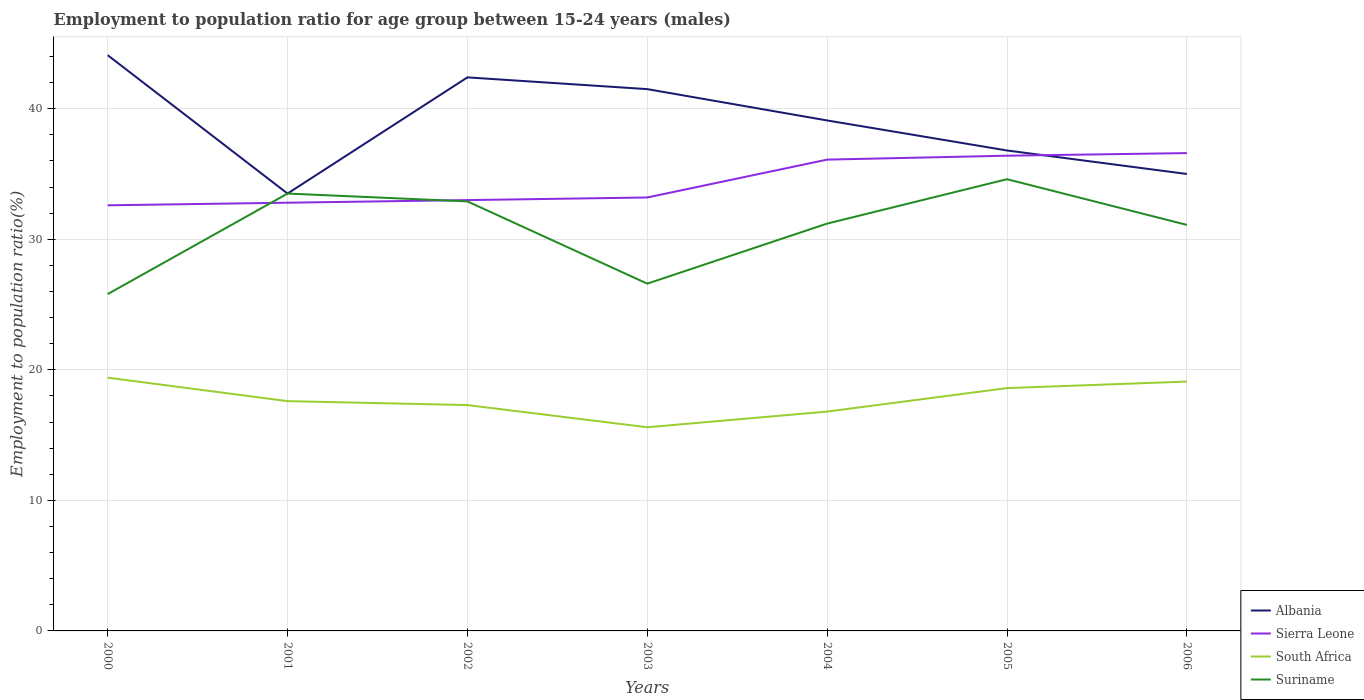How many different coloured lines are there?
Provide a short and direct response. 4. Does the line corresponding to Suriname intersect with the line corresponding to South Africa?
Provide a succinct answer. No. Is the number of lines equal to the number of legend labels?
Make the answer very short. Yes. Across all years, what is the maximum employment to population ratio in Albania?
Your answer should be very brief. 33.5. What is the total employment to population ratio in Suriname in the graph?
Offer a very short reply. -5.4. What is the difference between the highest and the second highest employment to population ratio in Sierra Leone?
Your response must be concise. 4. How many lines are there?
Provide a short and direct response. 4. What is the difference between two consecutive major ticks on the Y-axis?
Your response must be concise. 10. Does the graph contain any zero values?
Your answer should be very brief. No. What is the title of the graph?
Your answer should be very brief. Employment to population ratio for age group between 15-24 years (males). What is the Employment to population ratio(%) in Albania in 2000?
Your answer should be compact. 44.1. What is the Employment to population ratio(%) in Sierra Leone in 2000?
Provide a succinct answer. 32.6. What is the Employment to population ratio(%) in South Africa in 2000?
Your response must be concise. 19.4. What is the Employment to population ratio(%) of Suriname in 2000?
Your answer should be very brief. 25.8. What is the Employment to population ratio(%) in Albania in 2001?
Your answer should be very brief. 33.5. What is the Employment to population ratio(%) in Sierra Leone in 2001?
Give a very brief answer. 32.8. What is the Employment to population ratio(%) of South Africa in 2001?
Make the answer very short. 17.6. What is the Employment to population ratio(%) in Suriname in 2001?
Offer a terse response. 33.5. What is the Employment to population ratio(%) in Albania in 2002?
Ensure brevity in your answer.  42.4. What is the Employment to population ratio(%) of Sierra Leone in 2002?
Give a very brief answer. 33. What is the Employment to population ratio(%) of South Africa in 2002?
Provide a short and direct response. 17.3. What is the Employment to population ratio(%) in Suriname in 2002?
Offer a very short reply. 32.9. What is the Employment to population ratio(%) of Albania in 2003?
Your answer should be compact. 41.5. What is the Employment to population ratio(%) of Sierra Leone in 2003?
Provide a short and direct response. 33.2. What is the Employment to population ratio(%) of South Africa in 2003?
Your answer should be compact. 15.6. What is the Employment to population ratio(%) in Suriname in 2003?
Make the answer very short. 26.6. What is the Employment to population ratio(%) of Albania in 2004?
Give a very brief answer. 39.1. What is the Employment to population ratio(%) of Sierra Leone in 2004?
Offer a very short reply. 36.1. What is the Employment to population ratio(%) in South Africa in 2004?
Keep it short and to the point. 16.8. What is the Employment to population ratio(%) of Suriname in 2004?
Keep it short and to the point. 31.2. What is the Employment to population ratio(%) in Albania in 2005?
Offer a very short reply. 36.8. What is the Employment to population ratio(%) in Sierra Leone in 2005?
Ensure brevity in your answer.  36.4. What is the Employment to population ratio(%) in South Africa in 2005?
Provide a succinct answer. 18.6. What is the Employment to population ratio(%) in Suriname in 2005?
Ensure brevity in your answer.  34.6. What is the Employment to population ratio(%) in Sierra Leone in 2006?
Your answer should be very brief. 36.6. What is the Employment to population ratio(%) of South Africa in 2006?
Offer a very short reply. 19.1. What is the Employment to population ratio(%) in Suriname in 2006?
Ensure brevity in your answer.  31.1. Across all years, what is the maximum Employment to population ratio(%) of Albania?
Your answer should be very brief. 44.1. Across all years, what is the maximum Employment to population ratio(%) of Sierra Leone?
Your answer should be compact. 36.6. Across all years, what is the maximum Employment to population ratio(%) of South Africa?
Your response must be concise. 19.4. Across all years, what is the maximum Employment to population ratio(%) in Suriname?
Make the answer very short. 34.6. Across all years, what is the minimum Employment to population ratio(%) in Albania?
Offer a very short reply. 33.5. Across all years, what is the minimum Employment to population ratio(%) of Sierra Leone?
Provide a short and direct response. 32.6. Across all years, what is the minimum Employment to population ratio(%) in South Africa?
Your answer should be compact. 15.6. Across all years, what is the minimum Employment to population ratio(%) of Suriname?
Your answer should be compact. 25.8. What is the total Employment to population ratio(%) of Albania in the graph?
Provide a short and direct response. 272.4. What is the total Employment to population ratio(%) of Sierra Leone in the graph?
Your answer should be very brief. 240.7. What is the total Employment to population ratio(%) of South Africa in the graph?
Your response must be concise. 124.4. What is the total Employment to population ratio(%) of Suriname in the graph?
Your answer should be compact. 215.7. What is the difference between the Employment to population ratio(%) in Sierra Leone in 2000 and that in 2001?
Offer a very short reply. -0.2. What is the difference between the Employment to population ratio(%) of Sierra Leone in 2000 and that in 2002?
Offer a terse response. -0.4. What is the difference between the Employment to population ratio(%) of Albania in 2000 and that in 2003?
Keep it short and to the point. 2.6. What is the difference between the Employment to population ratio(%) of Sierra Leone in 2000 and that in 2003?
Make the answer very short. -0.6. What is the difference between the Employment to population ratio(%) in South Africa in 2000 and that in 2003?
Provide a succinct answer. 3.8. What is the difference between the Employment to population ratio(%) in Suriname in 2000 and that in 2003?
Provide a short and direct response. -0.8. What is the difference between the Employment to population ratio(%) of Albania in 2000 and that in 2004?
Give a very brief answer. 5. What is the difference between the Employment to population ratio(%) in South Africa in 2000 and that in 2004?
Keep it short and to the point. 2.6. What is the difference between the Employment to population ratio(%) in Suriname in 2000 and that in 2004?
Make the answer very short. -5.4. What is the difference between the Employment to population ratio(%) of Sierra Leone in 2000 and that in 2005?
Provide a short and direct response. -3.8. What is the difference between the Employment to population ratio(%) in Sierra Leone in 2000 and that in 2006?
Provide a succinct answer. -4. What is the difference between the Employment to population ratio(%) of South Africa in 2000 and that in 2006?
Provide a succinct answer. 0.3. What is the difference between the Employment to population ratio(%) of Suriname in 2001 and that in 2002?
Offer a terse response. 0.6. What is the difference between the Employment to population ratio(%) in South Africa in 2001 and that in 2003?
Keep it short and to the point. 2. What is the difference between the Employment to population ratio(%) of Suriname in 2001 and that in 2003?
Your response must be concise. 6.9. What is the difference between the Employment to population ratio(%) of Albania in 2001 and that in 2004?
Provide a short and direct response. -5.6. What is the difference between the Employment to population ratio(%) of Sierra Leone in 2001 and that in 2005?
Provide a succinct answer. -3.6. What is the difference between the Employment to population ratio(%) of Suriname in 2001 and that in 2005?
Your answer should be very brief. -1.1. What is the difference between the Employment to population ratio(%) of Sierra Leone in 2001 and that in 2006?
Keep it short and to the point. -3.8. What is the difference between the Employment to population ratio(%) in Suriname in 2001 and that in 2006?
Offer a very short reply. 2.4. What is the difference between the Employment to population ratio(%) of Albania in 2002 and that in 2003?
Give a very brief answer. 0.9. What is the difference between the Employment to population ratio(%) in Sierra Leone in 2002 and that in 2003?
Provide a succinct answer. -0.2. What is the difference between the Employment to population ratio(%) of South Africa in 2002 and that in 2003?
Give a very brief answer. 1.7. What is the difference between the Employment to population ratio(%) of Sierra Leone in 2002 and that in 2004?
Keep it short and to the point. -3.1. What is the difference between the Employment to population ratio(%) in South Africa in 2002 and that in 2004?
Provide a succinct answer. 0.5. What is the difference between the Employment to population ratio(%) of Albania in 2002 and that in 2005?
Keep it short and to the point. 5.6. What is the difference between the Employment to population ratio(%) in South Africa in 2002 and that in 2005?
Your answer should be very brief. -1.3. What is the difference between the Employment to population ratio(%) of Sierra Leone in 2002 and that in 2006?
Provide a short and direct response. -3.6. What is the difference between the Employment to population ratio(%) in South Africa in 2003 and that in 2004?
Provide a short and direct response. -1.2. What is the difference between the Employment to population ratio(%) in Sierra Leone in 2003 and that in 2005?
Provide a short and direct response. -3.2. What is the difference between the Employment to population ratio(%) in South Africa in 2003 and that in 2005?
Offer a very short reply. -3. What is the difference between the Employment to population ratio(%) of Sierra Leone in 2003 and that in 2006?
Make the answer very short. -3.4. What is the difference between the Employment to population ratio(%) of South Africa in 2003 and that in 2006?
Provide a succinct answer. -3.5. What is the difference between the Employment to population ratio(%) of South Africa in 2004 and that in 2005?
Your answer should be compact. -1.8. What is the difference between the Employment to population ratio(%) in Albania in 2004 and that in 2006?
Make the answer very short. 4.1. What is the difference between the Employment to population ratio(%) in Sierra Leone in 2004 and that in 2006?
Your answer should be compact. -0.5. What is the difference between the Employment to population ratio(%) of Suriname in 2004 and that in 2006?
Make the answer very short. 0.1. What is the difference between the Employment to population ratio(%) of Albania in 2005 and that in 2006?
Your response must be concise. 1.8. What is the difference between the Employment to population ratio(%) in Sierra Leone in 2005 and that in 2006?
Your answer should be very brief. -0.2. What is the difference between the Employment to population ratio(%) of Suriname in 2005 and that in 2006?
Your answer should be compact. 3.5. What is the difference between the Employment to population ratio(%) in Sierra Leone in 2000 and the Employment to population ratio(%) in South Africa in 2001?
Your answer should be very brief. 15. What is the difference between the Employment to population ratio(%) of Sierra Leone in 2000 and the Employment to population ratio(%) of Suriname in 2001?
Keep it short and to the point. -0.9. What is the difference between the Employment to population ratio(%) of South Africa in 2000 and the Employment to population ratio(%) of Suriname in 2001?
Your answer should be very brief. -14.1. What is the difference between the Employment to population ratio(%) of Albania in 2000 and the Employment to population ratio(%) of Sierra Leone in 2002?
Ensure brevity in your answer.  11.1. What is the difference between the Employment to population ratio(%) of Albania in 2000 and the Employment to population ratio(%) of South Africa in 2002?
Ensure brevity in your answer.  26.8. What is the difference between the Employment to population ratio(%) in Sierra Leone in 2000 and the Employment to population ratio(%) in South Africa in 2002?
Ensure brevity in your answer.  15.3. What is the difference between the Employment to population ratio(%) of Sierra Leone in 2000 and the Employment to population ratio(%) of Suriname in 2002?
Provide a succinct answer. -0.3. What is the difference between the Employment to population ratio(%) of South Africa in 2000 and the Employment to population ratio(%) of Suriname in 2002?
Provide a short and direct response. -13.5. What is the difference between the Employment to population ratio(%) in Albania in 2000 and the Employment to population ratio(%) in Sierra Leone in 2003?
Make the answer very short. 10.9. What is the difference between the Employment to population ratio(%) of Albania in 2000 and the Employment to population ratio(%) of Suriname in 2003?
Provide a succinct answer. 17.5. What is the difference between the Employment to population ratio(%) in Sierra Leone in 2000 and the Employment to population ratio(%) in Suriname in 2003?
Your answer should be very brief. 6. What is the difference between the Employment to population ratio(%) in South Africa in 2000 and the Employment to population ratio(%) in Suriname in 2003?
Your response must be concise. -7.2. What is the difference between the Employment to population ratio(%) of Albania in 2000 and the Employment to population ratio(%) of Sierra Leone in 2004?
Make the answer very short. 8. What is the difference between the Employment to population ratio(%) of Albania in 2000 and the Employment to population ratio(%) of South Africa in 2004?
Make the answer very short. 27.3. What is the difference between the Employment to population ratio(%) of Sierra Leone in 2000 and the Employment to population ratio(%) of South Africa in 2004?
Provide a succinct answer. 15.8. What is the difference between the Employment to population ratio(%) of South Africa in 2000 and the Employment to population ratio(%) of Suriname in 2004?
Provide a short and direct response. -11.8. What is the difference between the Employment to population ratio(%) in Albania in 2000 and the Employment to population ratio(%) in South Africa in 2005?
Offer a very short reply. 25.5. What is the difference between the Employment to population ratio(%) in South Africa in 2000 and the Employment to population ratio(%) in Suriname in 2005?
Ensure brevity in your answer.  -15.2. What is the difference between the Employment to population ratio(%) in Albania in 2000 and the Employment to population ratio(%) in South Africa in 2006?
Your answer should be very brief. 25. What is the difference between the Employment to population ratio(%) of Albania in 2000 and the Employment to population ratio(%) of Suriname in 2006?
Provide a succinct answer. 13. What is the difference between the Employment to population ratio(%) in Sierra Leone in 2000 and the Employment to population ratio(%) in South Africa in 2006?
Make the answer very short. 13.5. What is the difference between the Employment to population ratio(%) of South Africa in 2000 and the Employment to population ratio(%) of Suriname in 2006?
Your answer should be very brief. -11.7. What is the difference between the Employment to population ratio(%) of Albania in 2001 and the Employment to population ratio(%) of Suriname in 2002?
Offer a terse response. 0.6. What is the difference between the Employment to population ratio(%) of Sierra Leone in 2001 and the Employment to population ratio(%) of South Africa in 2002?
Keep it short and to the point. 15.5. What is the difference between the Employment to population ratio(%) in South Africa in 2001 and the Employment to population ratio(%) in Suriname in 2002?
Keep it short and to the point. -15.3. What is the difference between the Employment to population ratio(%) in Sierra Leone in 2001 and the Employment to population ratio(%) in South Africa in 2003?
Make the answer very short. 17.2. What is the difference between the Employment to population ratio(%) of Albania in 2001 and the Employment to population ratio(%) of Sierra Leone in 2004?
Your answer should be compact. -2.6. What is the difference between the Employment to population ratio(%) in Albania in 2001 and the Employment to population ratio(%) in South Africa in 2004?
Give a very brief answer. 16.7. What is the difference between the Employment to population ratio(%) in Sierra Leone in 2001 and the Employment to population ratio(%) in Suriname in 2004?
Provide a short and direct response. 1.6. What is the difference between the Employment to population ratio(%) in South Africa in 2001 and the Employment to population ratio(%) in Suriname in 2004?
Your answer should be compact. -13.6. What is the difference between the Employment to population ratio(%) of Albania in 2001 and the Employment to population ratio(%) of South Africa in 2005?
Provide a short and direct response. 14.9. What is the difference between the Employment to population ratio(%) in Sierra Leone in 2001 and the Employment to population ratio(%) in South Africa in 2005?
Keep it short and to the point. 14.2. What is the difference between the Employment to population ratio(%) of South Africa in 2001 and the Employment to population ratio(%) of Suriname in 2005?
Offer a very short reply. -17. What is the difference between the Employment to population ratio(%) in Albania in 2001 and the Employment to population ratio(%) in South Africa in 2006?
Your answer should be very brief. 14.4. What is the difference between the Employment to population ratio(%) of Albania in 2001 and the Employment to population ratio(%) of Suriname in 2006?
Ensure brevity in your answer.  2.4. What is the difference between the Employment to population ratio(%) in Sierra Leone in 2001 and the Employment to population ratio(%) in Suriname in 2006?
Keep it short and to the point. 1.7. What is the difference between the Employment to population ratio(%) in Albania in 2002 and the Employment to population ratio(%) in South Africa in 2003?
Offer a very short reply. 26.8. What is the difference between the Employment to population ratio(%) of Albania in 2002 and the Employment to population ratio(%) of Suriname in 2003?
Your answer should be compact. 15.8. What is the difference between the Employment to population ratio(%) of Sierra Leone in 2002 and the Employment to population ratio(%) of Suriname in 2003?
Keep it short and to the point. 6.4. What is the difference between the Employment to population ratio(%) of South Africa in 2002 and the Employment to population ratio(%) of Suriname in 2003?
Your answer should be compact. -9.3. What is the difference between the Employment to population ratio(%) of Albania in 2002 and the Employment to population ratio(%) of South Africa in 2004?
Make the answer very short. 25.6. What is the difference between the Employment to population ratio(%) in Sierra Leone in 2002 and the Employment to population ratio(%) in Suriname in 2004?
Provide a succinct answer. 1.8. What is the difference between the Employment to population ratio(%) of South Africa in 2002 and the Employment to population ratio(%) of Suriname in 2004?
Offer a very short reply. -13.9. What is the difference between the Employment to population ratio(%) in Albania in 2002 and the Employment to population ratio(%) in Sierra Leone in 2005?
Give a very brief answer. 6. What is the difference between the Employment to population ratio(%) of Albania in 2002 and the Employment to population ratio(%) of South Africa in 2005?
Offer a terse response. 23.8. What is the difference between the Employment to population ratio(%) in Albania in 2002 and the Employment to population ratio(%) in Suriname in 2005?
Ensure brevity in your answer.  7.8. What is the difference between the Employment to population ratio(%) in Sierra Leone in 2002 and the Employment to population ratio(%) in South Africa in 2005?
Make the answer very short. 14.4. What is the difference between the Employment to population ratio(%) of South Africa in 2002 and the Employment to population ratio(%) of Suriname in 2005?
Your answer should be compact. -17.3. What is the difference between the Employment to population ratio(%) in Albania in 2002 and the Employment to population ratio(%) in Sierra Leone in 2006?
Your answer should be very brief. 5.8. What is the difference between the Employment to population ratio(%) of Albania in 2002 and the Employment to population ratio(%) of South Africa in 2006?
Your answer should be compact. 23.3. What is the difference between the Employment to population ratio(%) in Sierra Leone in 2002 and the Employment to population ratio(%) in South Africa in 2006?
Make the answer very short. 13.9. What is the difference between the Employment to population ratio(%) in Sierra Leone in 2002 and the Employment to population ratio(%) in Suriname in 2006?
Provide a short and direct response. 1.9. What is the difference between the Employment to population ratio(%) in Albania in 2003 and the Employment to population ratio(%) in Sierra Leone in 2004?
Ensure brevity in your answer.  5.4. What is the difference between the Employment to population ratio(%) in Albania in 2003 and the Employment to population ratio(%) in South Africa in 2004?
Provide a short and direct response. 24.7. What is the difference between the Employment to population ratio(%) in Sierra Leone in 2003 and the Employment to population ratio(%) in South Africa in 2004?
Your answer should be very brief. 16.4. What is the difference between the Employment to population ratio(%) in South Africa in 2003 and the Employment to population ratio(%) in Suriname in 2004?
Ensure brevity in your answer.  -15.6. What is the difference between the Employment to population ratio(%) in Albania in 2003 and the Employment to population ratio(%) in South Africa in 2005?
Offer a terse response. 22.9. What is the difference between the Employment to population ratio(%) of Sierra Leone in 2003 and the Employment to population ratio(%) of Suriname in 2005?
Provide a succinct answer. -1.4. What is the difference between the Employment to population ratio(%) in Albania in 2003 and the Employment to population ratio(%) in Sierra Leone in 2006?
Offer a very short reply. 4.9. What is the difference between the Employment to population ratio(%) in Albania in 2003 and the Employment to population ratio(%) in South Africa in 2006?
Offer a very short reply. 22.4. What is the difference between the Employment to population ratio(%) of Albania in 2003 and the Employment to population ratio(%) of Suriname in 2006?
Your answer should be very brief. 10.4. What is the difference between the Employment to population ratio(%) of South Africa in 2003 and the Employment to population ratio(%) of Suriname in 2006?
Ensure brevity in your answer.  -15.5. What is the difference between the Employment to population ratio(%) of Albania in 2004 and the Employment to population ratio(%) of Suriname in 2005?
Provide a succinct answer. 4.5. What is the difference between the Employment to population ratio(%) in Sierra Leone in 2004 and the Employment to population ratio(%) in South Africa in 2005?
Make the answer very short. 17.5. What is the difference between the Employment to population ratio(%) in South Africa in 2004 and the Employment to population ratio(%) in Suriname in 2005?
Your answer should be very brief. -17.8. What is the difference between the Employment to population ratio(%) of Albania in 2004 and the Employment to population ratio(%) of Sierra Leone in 2006?
Your answer should be very brief. 2.5. What is the difference between the Employment to population ratio(%) of Albania in 2004 and the Employment to population ratio(%) of South Africa in 2006?
Offer a terse response. 20. What is the difference between the Employment to population ratio(%) in Albania in 2004 and the Employment to population ratio(%) in Suriname in 2006?
Ensure brevity in your answer.  8. What is the difference between the Employment to population ratio(%) in South Africa in 2004 and the Employment to population ratio(%) in Suriname in 2006?
Ensure brevity in your answer.  -14.3. What is the difference between the Employment to population ratio(%) of Albania in 2005 and the Employment to population ratio(%) of Suriname in 2006?
Make the answer very short. 5.7. What is the difference between the Employment to population ratio(%) in Sierra Leone in 2005 and the Employment to population ratio(%) in South Africa in 2006?
Your answer should be very brief. 17.3. What is the difference between the Employment to population ratio(%) of South Africa in 2005 and the Employment to population ratio(%) of Suriname in 2006?
Offer a very short reply. -12.5. What is the average Employment to population ratio(%) of Albania per year?
Your response must be concise. 38.91. What is the average Employment to population ratio(%) of Sierra Leone per year?
Keep it short and to the point. 34.39. What is the average Employment to population ratio(%) of South Africa per year?
Your response must be concise. 17.77. What is the average Employment to population ratio(%) of Suriname per year?
Provide a short and direct response. 30.81. In the year 2000, what is the difference between the Employment to population ratio(%) in Albania and Employment to population ratio(%) in South Africa?
Offer a very short reply. 24.7. In the year 2000, what is the difference between the Employment to population ratio(%) in Sierra Leone and Employment to population ratio(%) in South Africa?
Make the answer very short. 13.2. In the year 2001, what is the difference between the Employment to population ratio(%) in Albania and Employment to population ratio(%) in Sierra Leone?
Provide a succinct answer. 0.7. In the year 2001, what is the difference between the Employment to population ratio(%) in Albania and Employment to population ratio(%) in South Africa?
Offer a terse response. 15.9. In the year 2001, what is the difference between the Employment to population ratio(%) of Albania and Employment to population ratio(%) of Suriname?
Keep it short and to the point. 0. In the year 2001, what is the difference between the Employment to population ratio(%) in South Africa and Employment to population ratio(%) in Suriname?
Keep it short and to the point. -15.9. In the year 2002, what is the difference between the Employment to population ratio(%) of Albania and Employment to population ratio(%) of South Africa?
Your answer should be compact. 25.1. In the year 2002, what is the difference between the Employment to population ratio(%) of Albania and Employment to population ratio(%) of Suriname?
Your answer should be compact. 9.5. In the year 2002, what is the difference between the Employment to population ratio(%) of Sierra Leone and Employment to population ratio(%) of South Africa?
Keep it short and to the point. 15.7. In the year 2002, what is the difference between the Employment to population ratio(%) of South Africa and Employment to population ratio(%) of Suriname?
Give a very brief answer. -15.6. In the year 2003, what is the difference between the Employment to population ratio(%) of Albania and Employment to population ratio(%) of South Africa?
Ensure brevity in your answer.  25.9. In the year 2003, what is the difference between the Employment to population ratio(%) of Sierra Leone and Employment to population ratio(%) of Suriname?
Ensure brevity in your answer.  6.6. In the year 2004, what is the difference between the Employment to population ratio(%) of Albania and Employment to population ratio(%) of South Africa?
Provide a short and direct response. 22.3. In the year 2004, what is the difference between the Employment to population ratio(%) of Sierra Leone and Employment to population ratio(%) of South Africa?
Make the answer very short. 19.3. In the year 2004, what is the difference between the Employment to population ratio(%) of South Africa and Employment to population ratio(%) of Suriname?
Provide a succinct answer. -14.4. In the year 2005, what is the difference between the Employment to population ratio(%) in Albania and Employment to population ratio(%) in Sierra Leone?
Provide a succinct answer. 0.4. In the year 2005, what is the difference between the Employment to population ratio(%) in Albania and Employment to population ratio(%) in Suriname?
Ensure brevity in your answer.  2.2. In the year 2005, what is the difference between the Employment to population ratio(%) of Sierra Leone and Employment to population ratio(%) of South Africa?
Give a very brief answer. 17.8. In the year 2005, what is the difference between the Employment to population ratio(%) of Sierra Leone and Employment to population ratio(%) of Suriname?
Offer a terse response. 1.8. In the year 2005, what is the difference between the Employment to population ratio(%) in South Africa and Employment to population ratio(%) in Suriname?
Give a very brief answer. -16. In the year 2006, what is the difference between the Employment to population ratio(%) in Albania and Employment to population ratio(%) in South Africa?
Your answer should be compact. 15.9. In the year 2006, what is the difference between the Employment to population ratio(%) in Sierra Leone and Employment to population ratio(%) in South Africa?
Offer a very short reply. 17.5. In the year 2006, what is the difference between the Employment to population ratio(%) of Sierra Leone and Employment to population ratio(%) of Suriname?
Your answer should be very brief. 5.5. What is the ratio of the Employment to population ratio(%) of Albania in 2000 to that in 2001?
Your response must be concise. 1.32. What is the ratio of the Employment to population ratio(%) in South Africa in 2000 to that in 2001?
Offer a terse response. 1.1. What is the ratio of the Employment to population ratio(%) of Suriname in 2000 to that in 2001?
Keep it short and to the point. 0.77. What is the ratio of the Employment to population ratio(%) in Albania in 2000 to that in 2002?
Give a very brief answer. 1.04. What is the ratio of the Employment to population ratio(%) in Sierra Leone in 2000 to that in 2002?
Your answer should be compact. 0.99. What is the ratio of the Employment to population ratio(%) in South Africa in 2000 to that in 2002?
Keep it short and to the point. 1.12. What is the ratio of the Employment to population ratio(%) of Suriname in 2000 to that in 2002?
Provide a short and direct response. 0.78. What is the ratio of the Employment to population ratio(%) of Albania in 2000 to that in 2003?
Keep it short and to the point. 1.06. What is the ratio of the Employment to population ratio(%) of Sierra Leone in 2000 to that in 2003?
Provide a short and direct response. 0.98. What is the ratio of the Employment to population ratio(%) in South Africa in 2000 to that in 2003?
Provide a short and direct response. 1.24. What is the ratio of the Employment to population ratio(%) of Suriname in 2000 to that in 2003?
Give a very brief answer. 0.97. What is the ratio of the Employment to population ratio(%) in Albania in 2000 to that in 2004?
Provide a succinct answer. 1.13. What is the ratio of the Employment to population ratio(%) in Sierra Leone in 2000 to that in 2004?
Your answer should be very brief. 0.9. What is the ratio of the Employment to population ratio(%) of South Africa in 2000 to that in 2004?
Keep it short and to the point. 1.15. What is the ratio of the Employment to population ratio(%) in Suriname in 2000 to that in 2004?
Provide a short and direct response. 0.83. What is the ratio of the Employment to population ratio(%) of Albania in 2000 to that in 2005?
Your answer should be very brief. 1.2. What is the ratio of the Employment to population ratio(%) in Sierra Leone in 2000 to that in 2005?
Your answer should be very brief. 0.9. What is the ratio of the Employment to population ratio(%) in South Africa in 2000 to that in 2005?
Your answer should be very brief. 1.04. What is the ratio of the Employment to population ratio(%) in Suriname in 2000 to that in 2005?
Offer a terse response. 0.75. What is the ratio of the Employment to population ratio(%) in Albania in 2000 to that in 2006?
Give a very brief answer. 1.26. What is the ratio of the Employment to population ratio(%) of Sierra Leone in 2000 to that in 2006?
Give a very brief answer. 0.89. What is the ratio of the Employment to population ratio(%) in South Africa in 2000 to that in 2006?
Keep it short and to the point. 1.02. What is the ratio of the Employment to population ratio(%) in Suriname in 2000 to that in 2006?
Ensure brevity in your answer.  0.83. What is the ratio of the Employment to population ratio(%) of Albania in 2001 to that in 2002?
Offer a terse response. 0.79. What is the ratio of the Employment to population ratio(%) in South Africa in 2001 to that in 2002?
Keep it short and to the point. 1.02. What is the ratio of the Employment to population ratio(%) of Suriname in 2001 to that in 2002?
Provide a short and direct response. 1.02. What is the ratio of the Employment to population ratio(%) of Albania in 2001 to that in 2003?
Your answer should be compact. 0.81. What is the ratio of the Employment to population ratio(%) in Sierra Leone in 2001 to that in 2003?
Ensure brevity in your answer.  0.99. What is the ratio of the Employment to population ratio(%) in South Africa in 2001 to that in 2003?
Your answer should be compact. 1.13. What is the ratio of the Employment to population ratio(%) in Suriname in 2001 to that in 2003?
Offer a very short reply. 1.26. What is the ratio of the Employment to population ratio(%) in Albania in 2001 to that in 2004?
Offer a terse response. 0.86. What is the ratio of the Employment to population ratio(%) in Sierra Leone in 2001 to that in 2004?
Your answer should be compact. 0.91. What is the ratio of the Employment to population ratio(%) in South Africa in 2001 to that in 2004?
Offer a very short reply. 1.05. What is the ratio of the Employment to population ratio(%) of Suriname in 2001 to that in 2004?
Offer a terse response. 1.07. What is the ratio of the Employment to population ratio(%) in Albania in 2001 to that in 2005?
Provide a short and direct response. 0.91. What is the ratio of the Employment to population ratio(%) in Sierra Leone in 2001 to that in 2005?
Give a very brief answer. 0.9. What is the ratio of the Employment to population ratio(%) of South Africa in 2001 to that in 2005?
Make the answer very short. 0.95. What is the ratio of the Employment to population ratio(%) of Suriname in 2001 to that in 2005?
Offer a terse response. 0.97. What is the ratio of the Employment to population ratio(%) in Albania in 2001 to that in 2006?
Your response must be concise. 0.96. What is the ratio of the Employment to population ratio(%) of Sierra Leone in 2001 to that in 2006?
Keep it short and to the point. 0.9. What is the ratio of the Employment to population ratio(%) in South Africa in 2001 to that in 2006?
Offer a very short reply. 0.92. What is the ratio of the Employment to population ratio(%) in Suriname in 2001 to that in 2006?
Keep it short and to the point. 1.08. What is the ratio of the Employment to population ratio(%) of Albania in 2002 to that in 2003?
Offer a very short reply. 1.02. What is the ratio of the Employment to population ratio(%) of South Africa in 2002 to that in 2003?
Ensure brevity in your answer.  1.11. What is the ratio of the Employment to population ratio(%) in Suriname in 2002 to that in 2003?
Ensure brevity in your answer.  1.24. What is the ratio of the Employment to population ratio(%) in Albania in 2002 to that in 2004?
Your answer should be compact. 1.08. What is the ratio of the Employment to population ratio(%) of Sierra Leone in 2002 to that in 2004?
Offer a terse response. 0.91. What is the ratio of the Employment to population ratio(%) in South Africa in 2002 to that in 2004?
Your answer should be compact. 1.03. What is the ratio of the Employment to population ratio(%) of Suriname in 2002 to that in 2004?
Offer a terse response. 1.05. What is the ratio of the Employment to population ratio(%) of Albania in 2002 to that in 2005?
Provide a short and direct response. 1.15. What is the ratio of the Employment to population ratio(%) of Sierra Leone in 2002 to that in 2005?
Offer a very short reply. 0.91. What is the ratio of the Employment to population ratio(%) in South Africa in 2002 to that in 2005?
Ensure brevity in your answer.  0.93. What is the ratio of the Employment to population ratio(%) of Suriname in 2002 to that in 2005?
Your response must be concise. 0.95. What is the ratio of the Employment to population ratio(%) in Albania in 2002 to that in 2006?
Give a very brief answer. 1.21. What is the ratio of the Employment to population ratio(%) in Sierra Leone in 2002 to that in 2006?
Give a very brief answer. 0.9. What is the ratio of the Employment to population ratio(%) of South Africa in 2002 to that in 2006?
Your answer should be compact. 0.91. What is the ratio of the Employment to population ratio(%) of Suriname in 2002 to that in 2006?
Give a very brief answer. 1.06. What is the ratio of the Employment to population ratio(%) of Albania in 2003 to that in 2004?
Offer a terse response. 1.06. What is the ratio of the Employment to population ratio(%) in Sierra Leone in 2003 to that in 2004?
Make the answer very short. 0.92. What is the ratio of the Employment to population ratio(%) of South Africa in 2003 to that in 2004?
Provide a short and direct response. 0.93. What is the ratio of the Employment to population ratio(%) of Suriname in 2003 to that in 2004?
Provide a succinct answer. 0.85. What is the ratio of the Employment to population ratio(%) of Albania in 2003 to that in 2005?
Offer a very short reply. 1.13. What is the ratio of the Employment to population ratio(%) of Sierra Leone in 2003 to that in 2005?
Your answer should be very brief. 0.91. What is the ratio of the Employment to population ratio(%) of South Africa in 2003 to that in 2005?
Offer a very short reply. 0.84. What is the ratio of the Employment to population ratio(%) in Suriname in 2003 to that in 2005?
Provide a succinct answer. 0.77. What is the ratio of the Employment to population ratio(%) of Albania in 2003 to that in 2006?
Your response must be concise. 1.19. What is the ratio of the Employment to population ratio(%) in Sierra Leone in 2003 to that in 2006?
Make the answer very short. 0.91. What is the ratio of the Employment to population ratio(%) of South Africa in 2003 to that in 2006?
Offer a terse response. 0.82. What is the ratio of the Employment to population ratio(%) in Suriname in 2003 to that in 2006?
Provide a short and direct response. 0.86. What is the ratio of the Employment to population ratio(%) in South Africa in 2004 to that in 2005?
Provide a short and direct response. 0.9. What is the ratio of the Employment to population ratio(%) of Suriname in 2004 to that in 2005?
Your answer should be very brief. 0.9. What is the ratio of the Employment to population ratio(%) in Albania in 2004 to that in 2006?
Offer a very short reply. 1.12. What is the ratio of the Employment to population ratio(%) in Sierra Leone in 2004 to that in 2006?
Offer a terse response. 0.99. What is the ratio of the Employment to population ratio(%) of South Africa in 2004 to that in 2006?
Your answer should be compact. 0.88. What is the ratio of the Employment to population ratio(%) in Albania in 2005 to that in 2006?
Offer a very short reply. 1.05. What is the ratio of the Employment to population ratio(%) of South Africa in 2005 to that in 2006?
Offer a very short reply. 0.97. What is the ratio of the Employment to population ratio(%) of Suriname in 2005 to that in 2006?
Your answer should be compact. 1.11. What is the difference between the highest and the second highest Employment to population ratio(%) in South Africa?
Make the answer very short. 0.3. What is the difference between the highest and the second highest Employment to population ratio(%) of Suriname?
Keep it short and to the point. 1.1. What is the difference between the highest and the lowest Employment to population ratio(%) of Albania?
Make the answer very short. 10.6. What is the difference between the highest and the lowest Employment to population ratio(%) in Sierra Leone?
Provide a succinct answer. 4. 